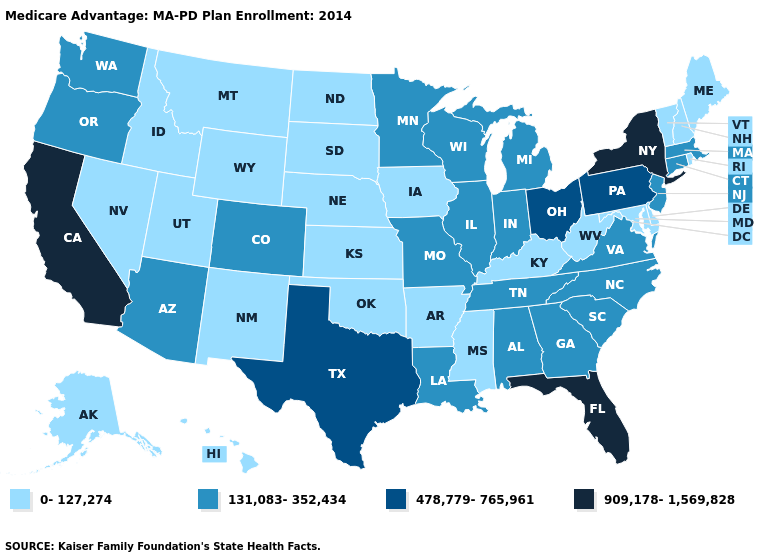What is the value of Vermont?
Quick response, please. 0-127,274. Does the map have missing data?
Keep it brief. No. How many symbols are there in the legend?
Concise answer only. 4. Among the states that border Louisiana , does Texas have the highest value?
Write a very short answer. Yes. Which states have the lowest value in the USA?
Give a very brief answer. Alaska, Arkansas, Delaware, Hawaii, Iowa, Idaho, Kansas, Kentucky, Maryland, Maine, Mississippi, Montana, North Dakota, Nebraska, New Hampshire, New Mexico, Nevada, Oklahoma, Rhode Island, South Dakota, Utah, Vermont, West Virginia, Wyoming. How many symbols are there in the legend?
Be succinct. 4. What is the value of West Virginia?
Quick response, please. 0-127,274. Does Virginia have the same value as Alabama?
Write a very short answer. Yes. Name the states that have a value in the range 478,779-765,961?
Be succinct. Ohio, Pennsylvania, Texas. Which states hav the highest value in the South?
Answer briefly. Florida. Which states have the lowest value in the USA?
Answer briefly. Alaska, Arkansas, Delaware, Hawaii, Iowa, Idaho, Kansas, Kentucky, Maryland, Maine, Mississippi, Montana, North Dakota, Nebraska, New Hampshire, New Mexico, Nevada, Oklahoma, Rhode Island, South Dakota, Utah, Vermont, West Virginia, Wyoming. What is the value of Oregon?
Concise answer only. 131,083-352,434. Does the map have missing data?
Give a very brief answer. No. Among the states that border Alabama , which have the highest value?
Quick response, please. Florida. Among the states that border Illinois , which have the lowest value?
Short answer required. Iowa, Kentucky. 